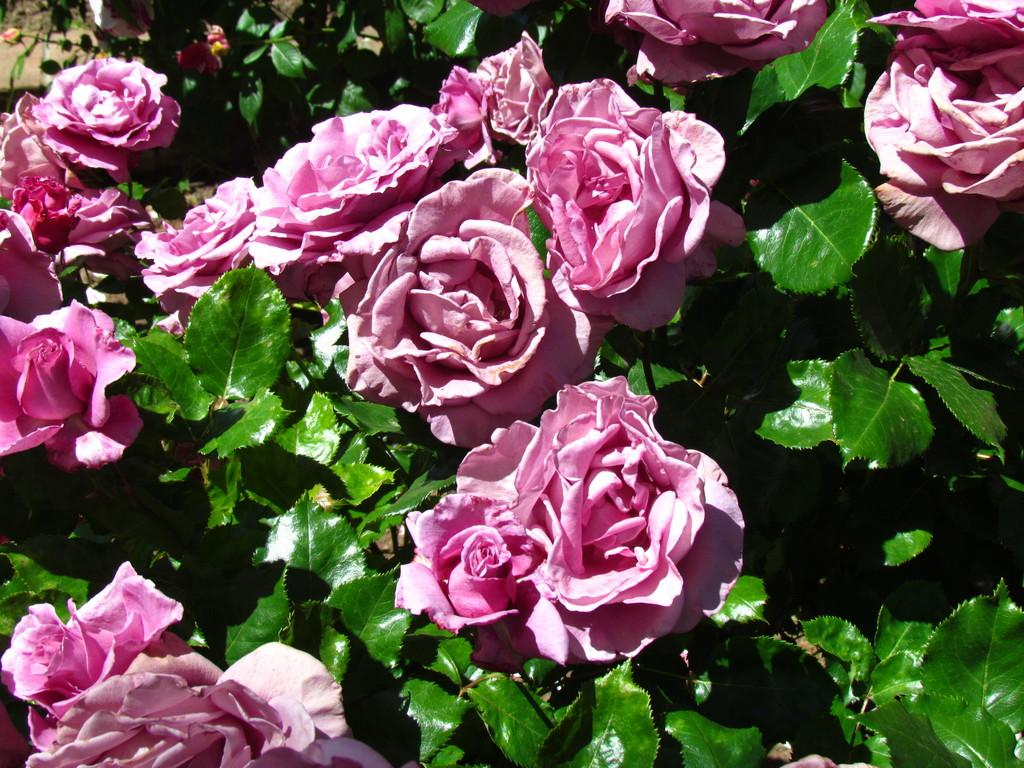What type of living organisms can be seen in the image? There are flowers and plants in the image. Can you describe the plants in the image? The plants in the image are not specified, but they are present alongside the flowers. What invention is being demonstrated by the hands in the image? There are no hands or inventions present in the image; it only features flowers and plants. 